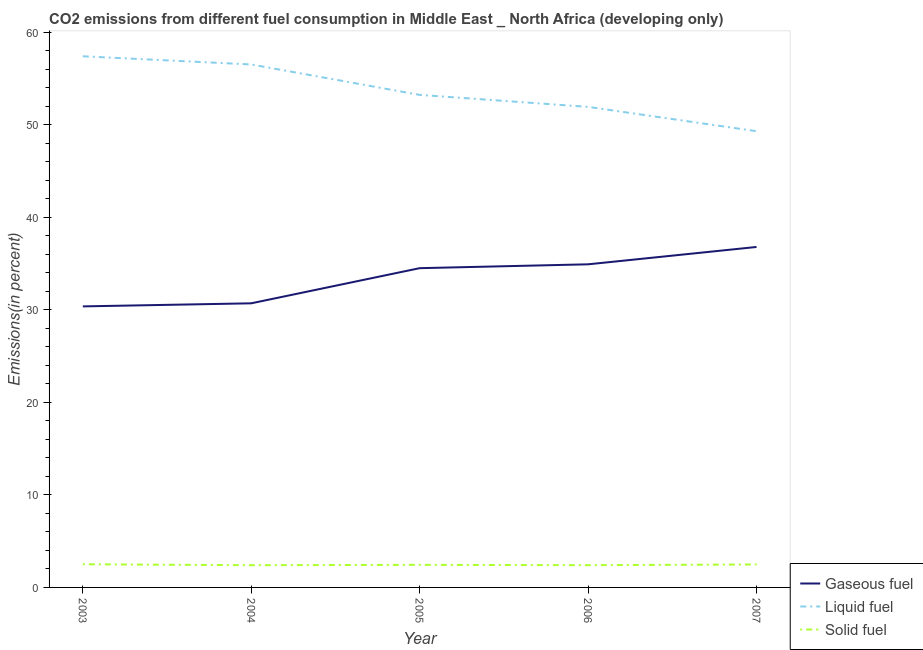Does the line corresponding to percentage of liquid fuel emission intersect with the line corresponding to percentage of solid fuel emission?
Your response must be concise. No. Is the number of lines equal to the number of legend labels?
Ensure brevity in your answer.  Yes. What is the percentage of liquid fuel emission in 2003?
Offer a very short reply. 57.42. Across all years, what is the maximum percentage of gaseous fuel emission?
Keep it short and to the point. 36.81. Across all years, what is the minimum percentage of gaseous fuel emission?
Offer a very short reply. 30.38. In which year was the percentage of liquid fuel emission maximum?
Keep it short and to the point. 2003. In which year was the percentage of solid fuel emission minimum?
Your answer should be compact. 2004. What is the total percentage of solid fuel emission in the graph?
Provide a short and direct response. 12.24. What is the difference between the percentage of solid fuel emission in 2003 and that in 2005?
Your answer should be very brief. 0.06. What is the difference between the percentage of gaseous fuel emission in 2004 and the percentage of solid fuel emission in 2003?
Offer a very short reply. 28.21. What is the average percentage of gaseous fuel emission per year?
Ensure brevity in your answer.  33.47. In the year 2003, what is the difference between the percentage of gaseous fuel emission and percentage of liquid fuel emission?
Provide a succinct answer. -27.04. What is the ratio of the percentage of liquid fuel emission in 2004 to that in 2006?
Offer a terse response. 1.09. Is the difference between the percentage of solid fuel emission in 2003 and 2006 greater than the difference between the percentage of liquid fuel emission in 2003 and 2006?
Offer a terse response. No. What is the difference between the highest and the second highest percentage of gaseous fuel emission?
Your response must be concise. 1.88. What is the difference between the highest and the lowest percentage of solid fuel emission?
Offer a very short reply. 0.1. In how many years, is the percentage of solid fuel emission greater than the average percentage of solid fuel emission taken over all years?
Your response must be concise. 2. Does the percentage of gaseous fuel emission monotonically increase over the years?
Provide a short and direct response. Yes. Is the percentage of gaseous fuel emission strictly less than the percentage of liquid fuel emission over the years?
Keep it short and to the point. Yes. How many lines are there?
Provide a short and direct response. 3. How many years are there in the graph?
Your answer should be very brief. 5. Are the values on the major ticks of Y-axis written in scientific E-notation?
Offer a very short reply. No. Where does the legend appear in the graph?
Make the answer very short. Bottom right. How many legend labels are there?
Your response must be concise. 3. How are the legend labels stacked?
Make the answer very short. Vertical. What is the title of the graph?
Give a very brief answer. CO2 emissions from different fuel consumption in Middle East _ North Africa (developing only). Does "Labor Market" appear as one of the legend labels in the graph?
Your answer should be compact. No. What is the label or title of the Y-axis?
Your answer should be compact. Emissions(in percent). What is the Emissions(in percent) in Gaseous fuel in 2003?
Make the answer very short. 30.38. What is the Emissions(in percent) of Liquid fuel in 2003?
Your answer should be very brief. 57.42. What is the Emissions(in percent) in Solid fuel in 2003?
Your response must be concise. 2.5. What is the Emissions(in percent) of Gaseous fuel in 2004?
Provide a succinct answer. 30.72. What is the Emissions(in percent) in Liquid fuel in 2004?
Provide a short and direct response. 56.54. What is the Emissions(in percent) in Solid fuel in 2004?
Keep it short and to the point. 2.4. What is the Emissions(in percent) in Gaseous fuel in 2005?
Provide a succinct answer. 34.52. What is the Emissions(in percent) in Liquid fuel in 2005?
Provide a short and direct response. 53.25. What is the Emissions(in percent) of Solid fuel in 2005?
Ensure brevity in your answer.  2.44. What is the Emissions(in percent) of Gaseous fuel in 2006?
Your answer should be compact. 34.93. What is the Emissions(in percent) in Liquid fuel in 2006?
Give a very brief answer. 51.95. What is the Emissions(in percent) of Solid fuel in 2006?
Provide a short and direct response. 2.41. What is the Emissions(in percent) in Gaseous fuel in 2007?
Provide a succinct answer. 36.81. What is the Emissions(in percent) in Liquid fuel in 2007?
Offer a terse response. 49.32. What is the Emissions(in percent) of Solid fuel in 2007?
Provide a short and direct response. 2.48. Across all years, what is the maximum Emissions(in percent) in Gaseous fuel?
Your answer should be very brief. 36.81. Across all years, what is the maximum Emissions(in percent) in Liquid fuel?
Your response must be concise. 57.42. Across all years, what is the maximum Emissions(in percent) in Solid fuel?
Make the answer very short. 2.5. Across all years, what is the minimum Emissions(in percent) in Gaseous fuel?
Offer a terse response. 30.38. Across all years, what is the minimum Emissions(in percent) of Liquid fuel?
Offer a terse response. 49.32. Across all years, what is the minimum Emissions(in percent) in Solid fuel?
Your answer should be very brief. 2.4. What is the total Emissions(in percent) of Gaseous fuel in the graph?
Offer a terse response. 167.36. What is the total Emissions(in percent) in Liquid fuel in the graph?
Your answer should be very brief. 268.49. What is the total Emissions(in percent) in Solid fuel in the graph?
Keep it short and to the point. 12.24. What is the difference between the Emissions(in percent) of Gaseous fuel in 2003 and that in 2004?
Your answer should be very brief. -0.33. What is the difference between the Emissions(in percent) in Liquid fuel in 2003 and that in 2004?
Keep it short and to the point. 0.89. What is the difference between the Emissions(in percent) in Solid fuel in 2003 and that in 2004?
Offer a very short reply. 0.1. What is the difference between the Emissions(in percent) in Gaseous fuel in 2003 and that in 2005?
Give a very brief answer. -4.13. What is the difference between the Emissions(in percent) of Liquid fuel in 2003 and that in 2005?
Offer a very short reply. 4.17. What is the difference between the Emissions(in percent) of Solid fuel in 2003 and that in 2005?
Offer a very short reply. 0.06. What is the difference between the Emissions(in percent) in Gaseous fuel in 2003 and that in 2006?
Your response must be concise. -4.55. What is the difference between the Emissions(in percent) in Liquid fuel in 2003 and that in 2006?
Make the answer very short. 5.47. What is the difference between the Emissions(in percent) of Solid fuel in 2003 and that in 2006?
Offer a terse response. 0.1. What is the difference between the Emissions(in percent) of Gaseous fuel in 2003 and that in 2007?
Offer a very short reply. -6.42. What is the difference between the Emissions(in percent) of Liquid fuel in 2003 and that in 2007?
Offer a very short reply. 8.1. What is the difference between the Emissions(in percent) in Solid fuel in 2003 and that in 2007?
Your answer should be very brief. 0.02. What is the difference between the Emissions(in percent) of Gaseous fuel in 2004 and that in 2005?
Provide a short and direct response. -3.8. What is the difference between the Emissions(in percent) in Liquid fuel in 2004 and that in 2005?
Your answer should be compact. 3.29. What is the difference between the Emissions(in percent) of Solid fuel in 2004 and that in 2005?
Provide a short and direct response. -0.04. What is the difference between the Emissions(in percent) in Gaseous fuel in 2004 and that in 2006?
Provide a short and direct response. -4.22. What is the difference between the Emissions(in percent) of Liquid fuel in 2004 and that in 2006?
Keep it short and to the point. 4.59. What is the difference between the Emissions(in percent) of Solid fuel in 2004 and that in 2006?
Provide a short and direct response. -0. What is the difference between the Emissions(in percent) of Gaseous fuel in 2004 and that in 2007?
Provide a short and direct response. -6.09. What is the difference between the Emissions(in percent) of Liquid fuel in 2004 and that in 2007?
Make the answer very short. 7.21. What is the difference between the Emissions(in percent) of Solid fuel in 2004 and that in 2007?
Provide a short and direct response. -0.08. What is the difference between the Emissions(in percent) of Gaseous fuel in 2005 and that in 2006?
Offer a terse response. -0.42. What is the difference between the Emissions(in percent) in Liquid fuel in 2005 and that in 2006?
Make the answer very short. 1.3. What is the difference between the Emissions(in percent) of Solid fuel in 2005 and that in 2006?
Offer a very short reply. 0.03. What is the difference between the Emissions(in percent) in Gaseous fuel in 2005 and that in 2007?
Offer a very short reply. -2.29. What is the difference between the Emissions(in percent) in Liquid fuel in 2005 and that in 2007?
Your answer should be compact. 3.93. What is the difference between the Emissions(in percent) in Solid fuel in 2005 and that in 2007?
Keep it short and to the point. -0.04. What is the difference between the Emissions(in percent) in Gaseous fuel in 2006 and that in 2007?
Ensure brevity in your answer.  -1.88. What is the difference between the Emissions(in percent) of Liquid fuel in 2006 and that in 2007?
Ensure brevity in your answer.  2.63. What is the difference between the Emissions(in percent) in Solid fuel in 2006 and that in 2007?
Give a very brief answer. -0.08. What is the difference between the Emissions(in percent) of Gaseous fuel in 2003 and the Emissions(in percent) of Liquid fuel in 2004?
Ensure brevity in your answer.  -26.15. What is the difference between the Emissions(in percent) in Gaseous fuel in 2003 and the Emissions(in percent) in Solid fuel in 2004?
Offer a terse response. 27.98. What is the difference between the Emissions(in percent) in Liquid fuel in 2003 and the Emissions(in percent) in Solid fuel in 2004?
Offer a terse response. 55.02. What is the difference between the Emissions(in percent) of Gaseous fuel in 2003 and the Emissions(in percent) of Liquid fuel in 2005?
Ensure brevity in your answer.  -22.87. What is the difference between the Emissions(in percent) in Gaseous fuel in 2003 and the Emissions(in percent) in Solid fuel in 2005?
Your response must be concise. 27.94. What is the difference between the Emissions(in percent) in Liquid fuel in 2003 and the Emissions(in percent) in Solid fuel in 2005?
Your response must be concise. 54.98. What is the difference between the Emissions(in percent) of Gaseous fuel in 2003 and the Emissions(in percent) of Liquid fuel in 2006?
Provide a short and direct response. -21.57. What is the difference between the Emissions(in percent) of Gaseous fuel in 2003 and the Emissions(in percent) of Solid fuel in 2006?
Your answer should be compact. 27.98. What is the difference between the Emissions(in percent) in Liquid fuel in 2003 and the Emissions(in percent) in Solid fuel in 2006?
Give a very brief answer. 55.02. What is the difference between the Emissions(in percent) in Gaseous fuel in 2003 and the Emissions(in percent) in Liquid fuel in 2007?
Offer a terse response. -18.94. What is the difference between the Emissions(in percent) of Gaseous fuel in 2003 and the Emissions(in percent) of Solid fuel in 2007?
Your answer should be compact. 27.9. What is the difference between the Emissions(in percent) of Liquid fuel in 2003 and the Emissions(in percent) of Solid fuel in 2007?
Your answer should be compact. 54.94. What is the difference between the Emissions(in percent) of Gaseous fuel in 2004 and the Emissions(in percent) of Liquid fuel in 2005?
Offer a terse response. -22.53. What is the difference between the Emissions(in percent) of Gaseous fuel in 2004 and the Emissions(in percent) of Solid fuel in 2005?
Your answer should be compact. 28.28. What is the difference between the Emissions(in percent) of Liquid fuel in 2004 and the Emissions(in percent) of Solid fuel in 2005?
Offer a terse response. 54.1. What is the difference between the Emissions(in percent) of Gaseous fuel in 2004 and the Emissions(in percent) of Liquid fuel in 2006?
Keep it short and to the point. -21.24. What is the difference between the Emissions(in percent) in Gaseous fuel in 2004 and the Emissions(in percent) in Solid fuel in 2006?
Your answer should be compact. 28.31. What is the difference between the Emissions(in percent) in Liquid fuel in 2004 and the Emissions(in percent) in Solid fuel in 2006?
Your answer should be very brief. 54.13. What is the difference between the Emissions(in percent) of Gaseous fuel in 2004 and the Emissions(in percent) of Liquid fuel in 2007?
Provide a short and direct response. -18.61. What is the difference between the Emissions(in percent) of Gaseous fuel in 2004 and the Emissions(in percent) of Solid fuel in 2007?
Provide a short and direct response. 28.23. What is the difference between the Emissions(in percent) in Liquid fuel in 2004 and the Emissions(in percent) in Solid fuel in 2007?
Give a very brief answer. 54.05. What is the difference between the Emissions(in percent) of Gaseous fuel in 2005 and the Emissions(in percent) of Liquid fuel in 2006?
Give a very brief answer. -17.44. What is the difference between the Emissions(in percent) of Gaseous fuel in 2005 and the Emissions(in percent) of Solid fuel in 2006?
Provide a short and direct response. 32.11. What is the difference between the Emissions(in percent) of Liquid fuel in 2005 and the Emissions(in percent) of Solid fuel in 2006?
Ensure brevity in your answer.  50.84. What is the difference between the Emissions(in percent) in Gaseous fuel in 2005 and the Emissions(in percent) in Liquid fuel in 2007?
Offer a terse response. -14.81. What is the difference between the Emissions(in percent) in Gaseous fuel in 2005 and the Emissions(in percent) in Solid fuel in 2007?
Offer a very short reply. 32.03. What is the difference between the Emissions(in percent) in Liquid fuel in 2005 and the Emissions(in percent) in Solid fuel in 2007?
Provide a succinct answer. 50.77. What is the difference between the Emissions(in percent) in Gaseous fuel in 2006 and the Emissions(in percent) in Liquid fuel in 2007?
Give a very brief answer. -14.39. What is the difference between the Emissions(in percent) of Gaseous fuel in 2006 and the Emissions(in percent) of Solid fuel in 2007?
Your answer should be compact. 32.45. What is the difference between the Emissions(in percent) in Liquid fuel in 2006 and the Emissions(in percent) in Solid fuel in 2007?
Your response must be concise. 49.47. What is the average Emissions(in percent) of Gaseous fuel per year?
Your response must be concise. 33.47. What is the average Emissions(in percent) of Liquid fuel per year?
Offer a terse response. 53.7. What is the average Emissions(in percent) in Solid fuel per year?
Your answer should be compact. 2.45. In the year 2003, what is the difference between the Emissions(in percent) of Gaseous fuel and Emissions(in percent) of Liquid fuel?
Offer a very short reply. -27.04. In the year 2003, what is the difference between the Emissions(in percent) of Gaseous fuel and Emissions(in percent) of Solid fuel?
Make the answer very short. 27.88. In the year 2003, what is the difference between the Emissions(in percent) of Liquid fuel and Emissions(in percent) of Solid fuel?
Offer a very short reply. 54.92. In the year 2004, what is the difference between the Emissions(in percent) in Gaseous fuel and Emissions(in percent) in Liquid fuel?
Your answer should be very brief. -25.82. In the year 2004, what is the difference between the Emissions(in percent) of Gaseous fuel and Emissions(in percent) of Solid fuel?
Give a very brief answer. 28.31. In the year 2004, what is the difference between the Emissions(in percent) of Liquid fuel and Emissions(in percent) of Solid fuel?
Provide a succinct answer. 54.14. In the year 2005, what is the difference between the Emissions(in percent) in Gaseous fuel and Emissions(in percent) in Liquid fuel?
Make the answer very short. -18.73. In the year 2005, what is the difference between the Emissions(in percent) in Gaseous fuel and Emissions(in percent) in Solid fuel?
Keep it short and to the point. 32.08. In the year 2005, what is the difference between the Emissions(in percent) in Liquid fuel and Emissions(in percent) in Solid fuel?
Make the answer very short. 50.81. In the year 2006, what is the difference between the Emissions(in percent) of Gaseous fuel and Emissions(in percent) of Liquid fuel?
Your answer should be very brief. -17.02. In the year 2006, what is the difference between the Emissions(in percent) of Gaseous fuel and Emissions(in percent) of Solid fuel?
Provide a succinct answer. 32.53. In the year 2006, what is the difference between the Emissions(in percent) of Liquid fuel and Emissions(in percent) of Solid fuel?
Provide a short and direct response. 49.55. In the year 2007, what is the difference between the Emissions(in percent) in Gaseous fuel and Emissions(in percent) in Liquid fuel?
Make the answer very short. -12.51. In the year 2007, what is the difference between the Emissions(in percent) in Gaseous fuel and Emissions(in percent) in Solid fuel?
Your answer should be compact. 34.33. In the year 2007, what is the difference between the Emissions(in percent) of Liquid fuel and Emissions(in percent) of Solid fuel?
Your answer should be very brief. 46.84. What is the ratio of the Emissions(in percent) of Gaseous fuel in 2003 to that in 2004?
Offer a very short reply. 0.99. What is the ratio of the Emissions(in percent) of Liquid fuel in 2003 to that in 2004?
Provide a short and direct response. 1.02. What is the ratio of the Emissions(in percent) in Solid fuel in 2003 to that in 2004?
Give a very brief answer. 1.04. What is the ratio of the Emissions(in percent) of Gaseous fuel in 2003 to that in 2005?
Give a very brief answer. 0.88. What is the ratio of the Emissions(in percent) in Liquid fuel in 2003 to that in 2005?
Your answer should be very brief. 1.08. What is the ratio of the Emissions(in percent) in Solid fuel in 2003 to that in 2005?
Offer a terse response. 1.03. What is the ratio of the Emissions(in percent) of Gaseous fuel in 2003 to that in 2006?
Keep it short and to the point. 0.87. What is the ratio of the Emissions(in percent) in Liquid fuel in 2003 to that in 2006?
Make the answer very short. 1.11. What is the ratio of the Emissions(in percent) in Solid fuel in 2003 to that in 2006?
Provide a succinct answer. 1.04. What is the ratio of the Emissions(in percent) in Gaseous fuel in 2003 to that in 2007?
Your response must be concise. 0.83. What is the ratio of the Emissions(in percent) of Liquid fuel in 2003 to that in 2007?
Keep it short and to the point. 1.16. What is the ratio of the Emissions(in percent) of Solid fuel in 2003 to that in 2007?
Offer a terse response. 1.01. What is the ratio of the Emissions(in percent) of Gaseous fuel in 2004 to that in 2005?
Provide a short and direct response. 0.89. What is the ratio of the Emissions(in percent) of Liquid fuel in 2004 to that in 2005?
Offer a terse response. 1.06. What is the ratio of the Emissions(in percent) of Solid fuel in 2004 to that in 2005?
Make the answer very short. 0.98. What is the ratio of the Emissions(in percent) of Gaseous fuel in 2004 to that in 2006?
Keep it short and to the point. 0.88. What is the ratio of the Emissions(in percent) of Liquid fuel in 2004 to that in 2006?
Provide a short and direct response. 1.09. What is the ratio of the Emissions(in percent) of Solid fuel in 2004 to that in 2006?
Your answer should be very brief. 1. What is the ratio of the Emissions(in percent) of Gaseous fuel in 2004 to that in 2007?
Ensure brevity in your answer.  0.83. What is the ratio of the Emissions(in percent) of Liquid fuel in 2004 to that in 2007?
Keep it short and to the point. 1.15. What is the ratio of the Emissions(in percent) in Solid fuel in 2004 to that in 2007?
Your response must be concise. 0.97. What is the ratio of the Emissions(in percent) of Gaseous fuel in 2005 to that in 2006?
Your response must be concise. 0.99. What is the ratio of the Emissions(in percent) of Solid fuel in 2005 to that in 2006?
Your answer should be very brief. 1.01. What is the ratio of the Emissions(in percent) in Gaseous fuel in 2005 to that in 2007?
Offer a very short reply. 0.94. What is the ratio of the Emissions(in percent) in Liquid fuel in 2005 to that in 2007?
Your answer should be compact. 1.08. What is the ratio of the Emissions(in percent) of Solid fuel in 2005 to that in 2007?
Offer a very short reply. 0.98. What is the ratio of the Emissions(in percent) of Gaseous fuel in 2006 to that in 2007?
Keep it short and to the point. 0.95. What is the ratio of the Emissions(in percent) of Liquid fuel in 2006 to that in 2007?
Ensure brevity in your answer.  1.05. What is the ratio of the Emissions(in percent) of Solid fuel in 2006 to that in 2007?
Your answer should be very brief. 0.97. What is the difference between the highest and the second highest Emissions(in percent) of Gaseous fuel?
Offer a very short reply. 1.88. What is the difference between the highest and the second highest Emissions(in percent) in Liquid fuel?
Make the answer very short. 0.89. What is the difference between the highest and the second highest Emissions(in percent) in Solid fuel?
Offer a very short reply. 0.02. What is the difference between the highest and the lowest Emissions(in percent) of Gaseous fuel?
Your answer should be very brief. 6.42. What is the difference between the highest and the lowest Emissions(in percent) in Liquid fuel?
Offer a terse response. 8.1. What is the difference between the highest and the lowest Emissions(in percent) of Solid fuel?
Offer a terse response. 0.1. 